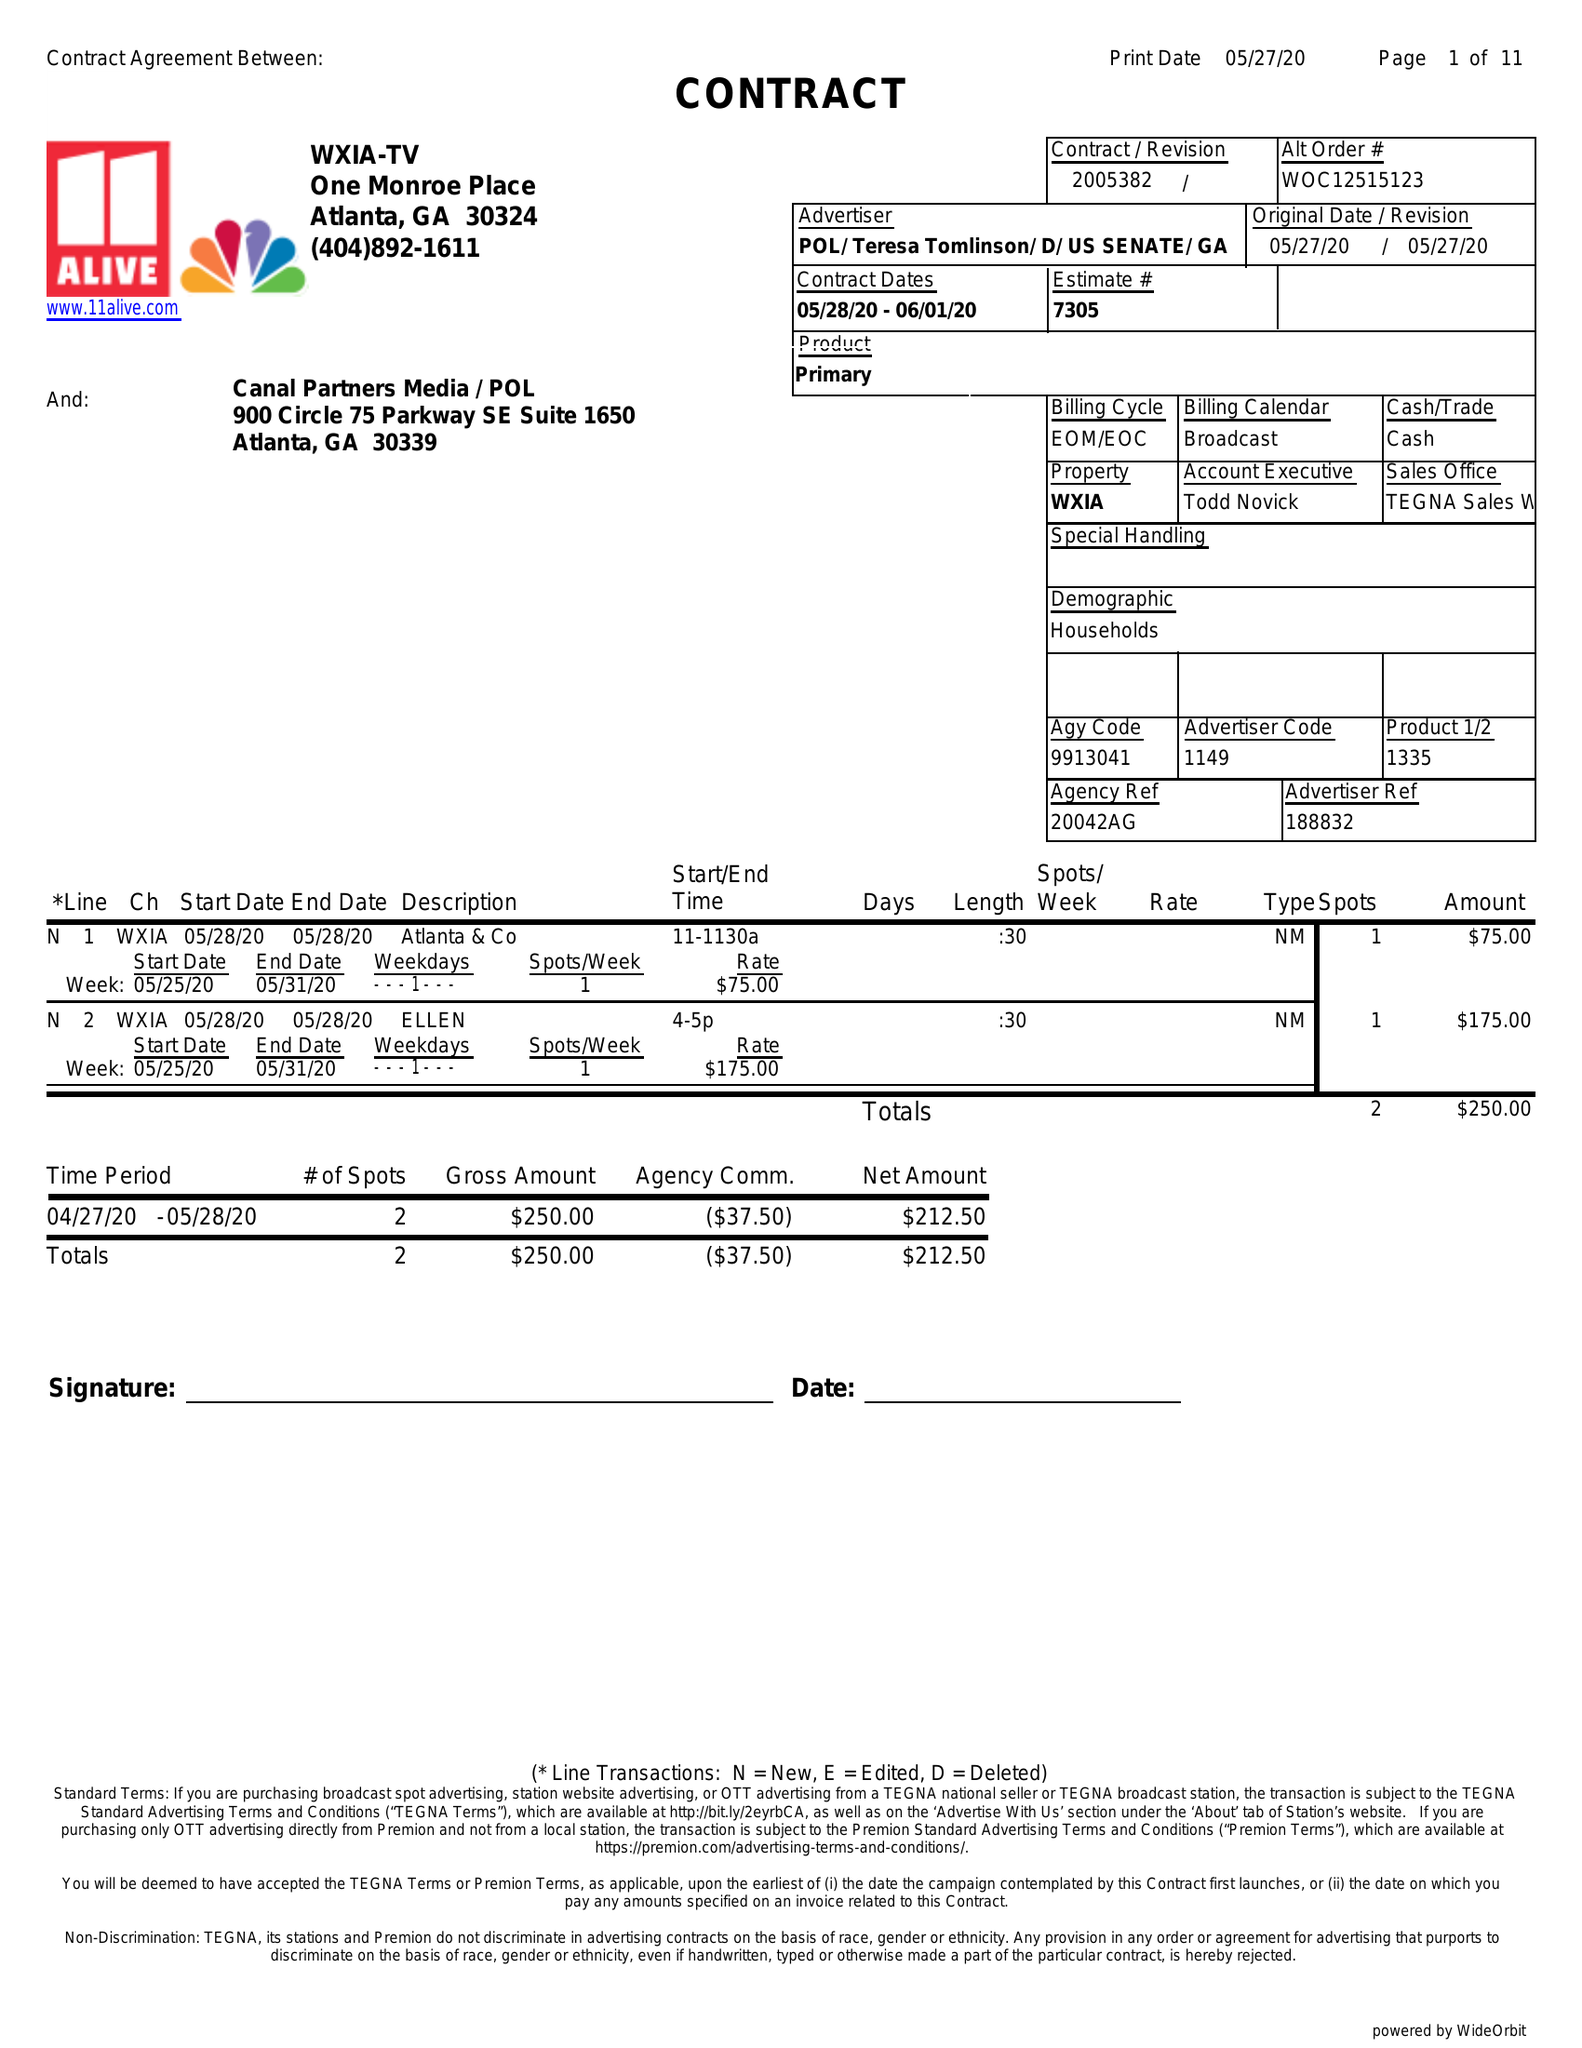What is the value for the flight_to?
Answer the question using a single word or phrase. 06/01/20 